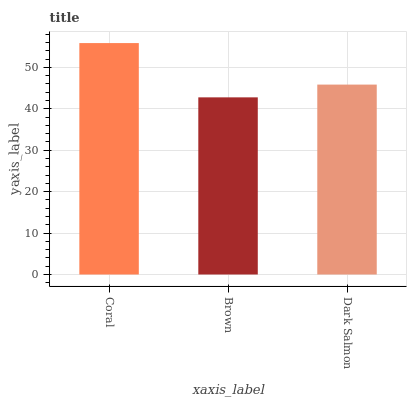Is Dark Salmon the minimum?
Answer yes or no. No. Is Dark Salmon the maximum?
Answer yes or no. No. Is Dark Salmon greater than Brown?
Answer yes or no. Yes. Is Brown less than Dark Salmon?
Answer yes or no. Yes. Is Brown greater than Dark Salmon?
Answer yes or no. No. Is Dark Salmon less than Brown?
Answer yes or no. No. Is Dark Salmon the high median?
Answer yes or no. Yes. Is Dark Salmon the low median?
Answer yes or no. Yes. Is Brown the high median?
Answer yes or no. No. Is Brown the low median?
Answer yes or no. No. 